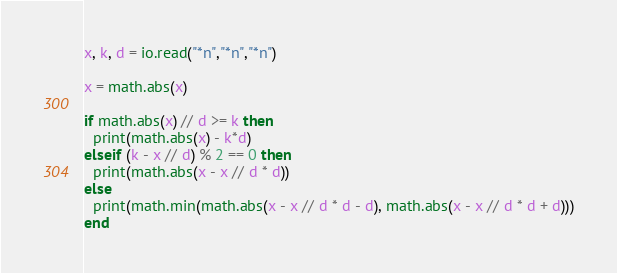<code> <loc_0><loc_0><loc_500><loc_500><_Lua_>x, k, d = io.read("*n","*n","*n")

x = math.abs(x)

if math.abs(x) // d >= k then
  print(math.abs(x) - k*d)
elseif (k - x // d) % 2 == 0 then
  print(math.abs(x - x // d * d))
else
  print(math.min(math.abs(x - x // d * d - d), math.abs(x - x // d * d + d)))
end
</code> 